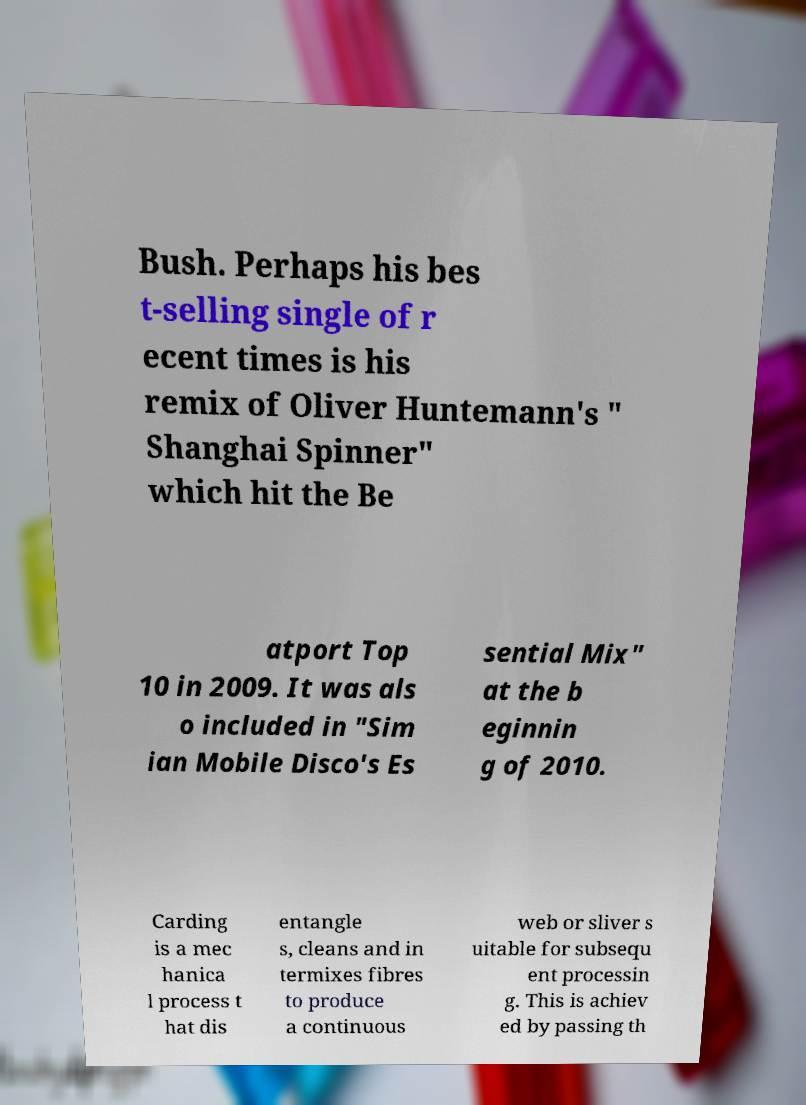Could you assist in decoding the text presented in this image and type it out clearly? Bush. Perhaps his bes t-selling single of r ecent times is his remix of Oliver Huntemann's " Shanghai Spinner" which hit the Be atport Top 10 in 2009. It was als o included in "Sim ian Mobile Disco's Es sential Mix" at the b eginnin g of 2010. Carding is a mec hanica l process t hat dis entangle s, cleans and in termixes fibres to produce a continuous web or sliver s uitable for subsequ ent processin g. This is achiev ed by passing th 